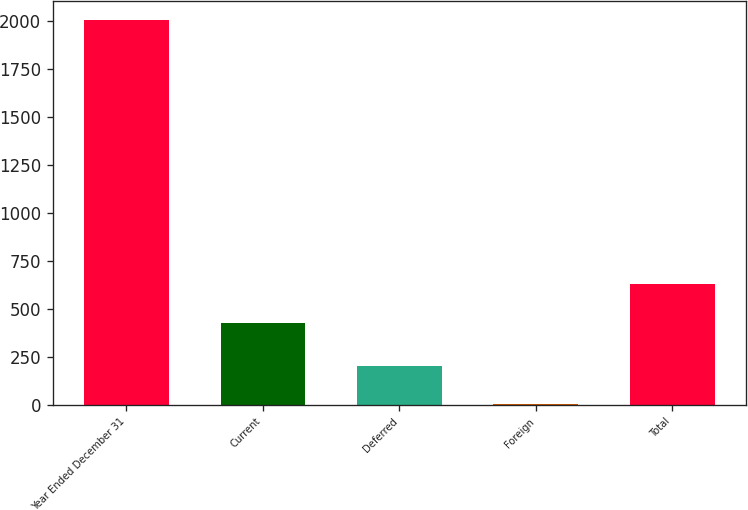Convert chart. <chart><loc_0><loc_0><loc_500><loc_500><bar_chart><fcel>Year Ended December 31<fcel>Current<fcel>Deferred<fcel>Foreign<fcel>Total<nl><fcel>2004<fcel>425.8<fcel>200.94<fcel>0.6<fcel>626.14<nl></chart> 